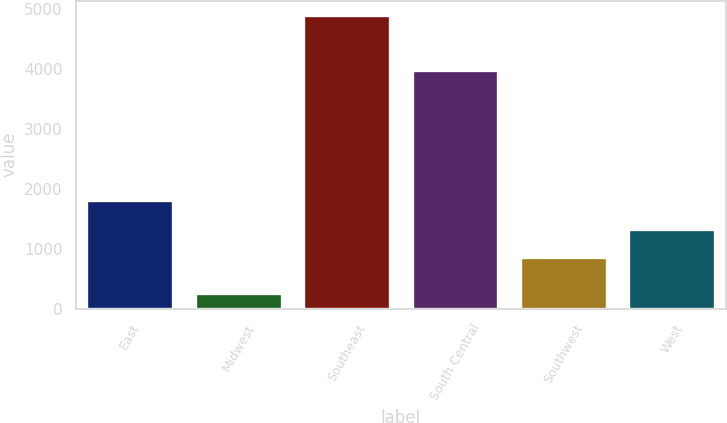Convert chart. <chart><loc_0><loc_0><loc_500><loc_500><bar_chart><fcel>East<fcel>Midwest<fcel>Southeast<fcel>South Central<fcel>Southwest<fcel>West<nl><fcel>1818<fcel>260<fcel>4898<fcel>3989<fcel>864<fcel>1327.8<nl></chart> 